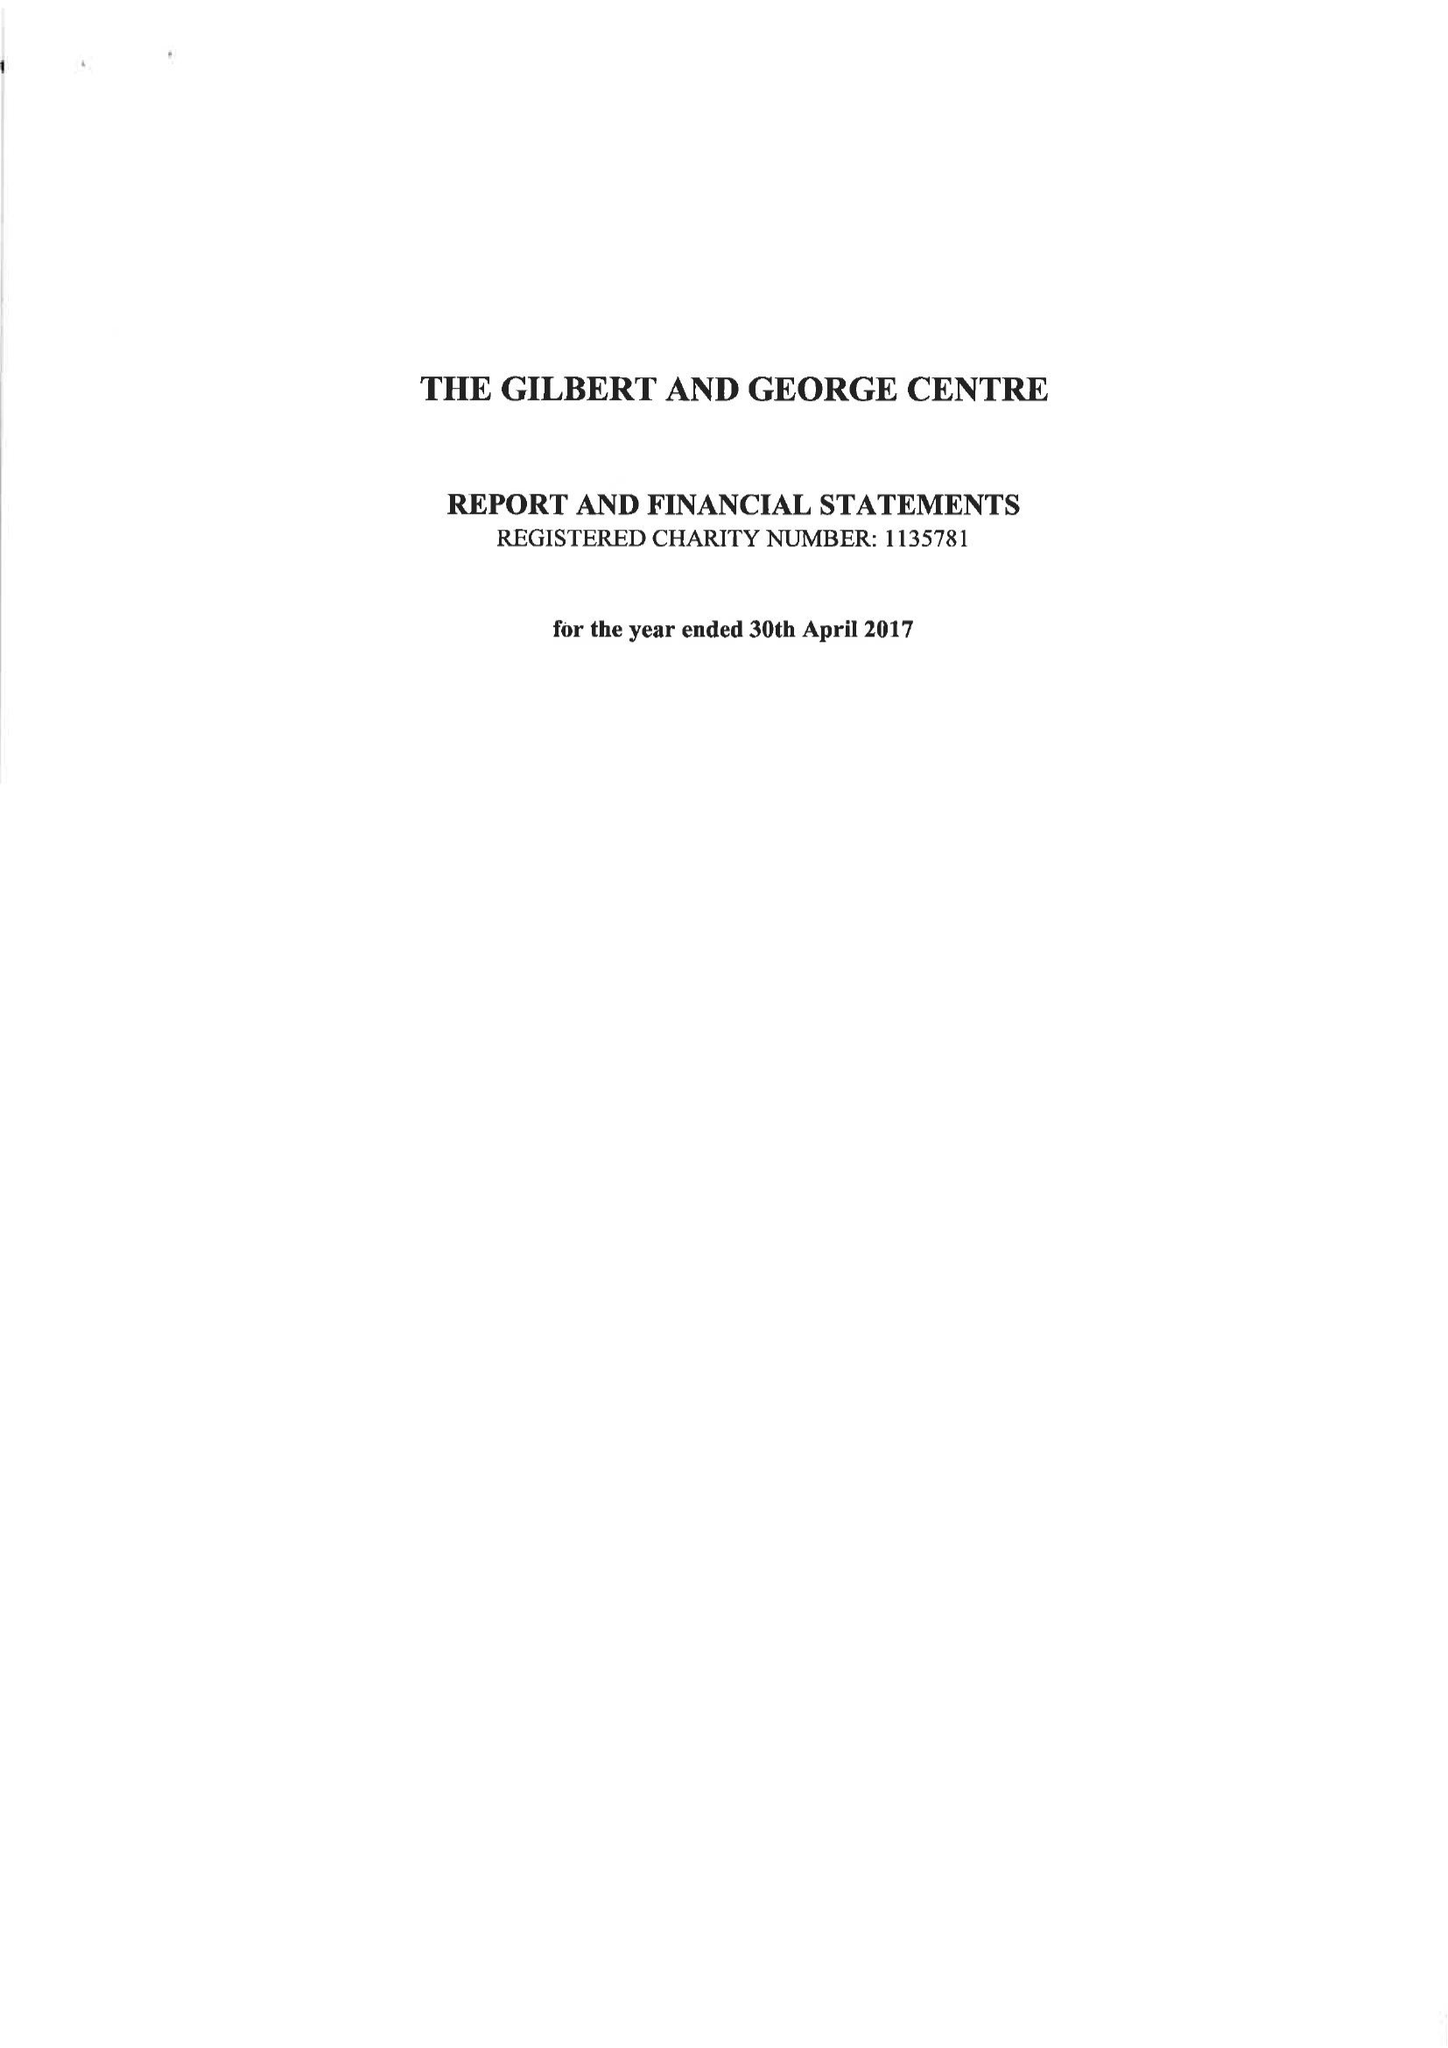What is the value for the spending_annually_in_british_pounds?
Answer the question using a single word or phrase. 24167.00 